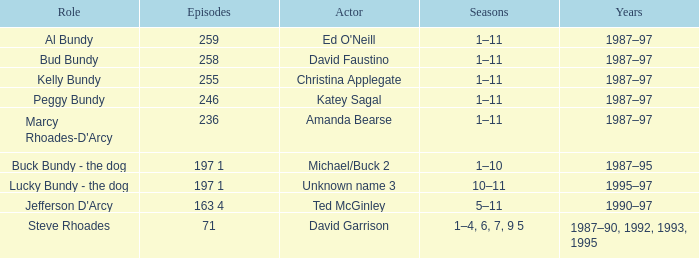How many years did the role of Steve Rhoades last? 1987–90, 1992, 1993, 1995. Help me parse the entirety of this table. {'header': ['Role', 'Episodes', 'Actor', 'Seasons', 'Years'], 'rows': [['Al Bundy', '259', "Ed O'Neill", '1–11', '1987–97'], ['Bud Bundy', '258', 'David Faustino', '1–11', '1987–97'], ['Kelly Bundy', '255', 'Christina Applegate', '1–11', '1987–97'], ['Peggy Bundy', '246', 'Katey Sagal', '1–11', '1987–97'], ["Marcy Rhoades-D'Arcy", '236', 'Amanda Bearse', '1–11', '1987–97'], ['Buck Bundy - the dog', '197 1', 'Michael/Buck 2', '1–10', '1987–95'], ['Lucky Bundy - the dog', '197 1', 'Unknown name 3', '10–11', '1995–97'], ["Jefferson D'Arcy", '163 4', 'Ted McGinley', '5–11', '1990–97'], ['Steve Rhoades', '71', 'David Garrison', '1–4, 6, 7, 9 5', '1987–90, 1992, 1993, 1995']]} 